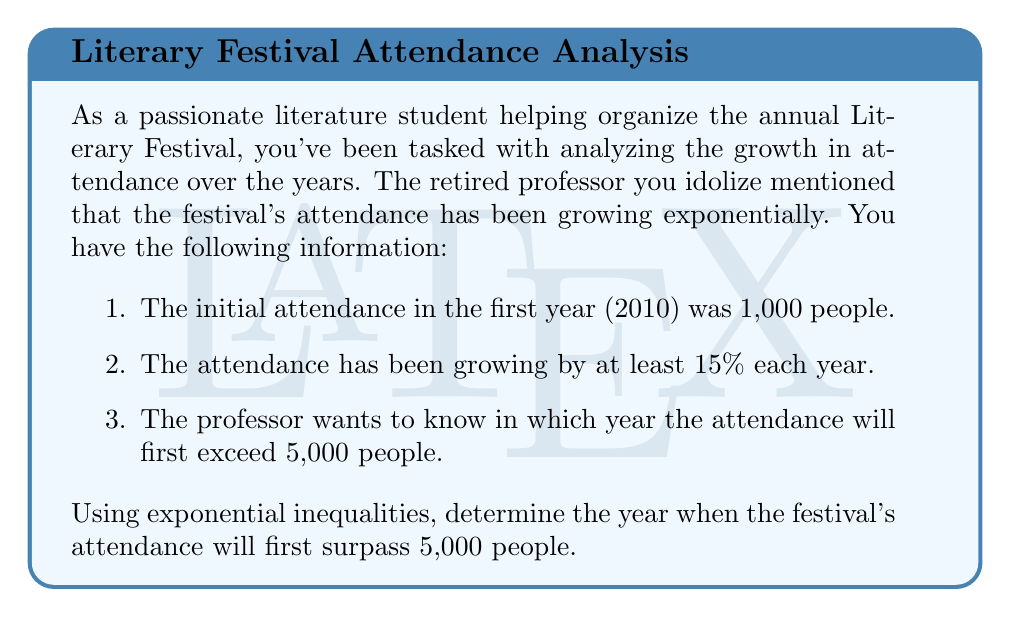Solve this math problem. Let's approach this step-by-step using exponential inequalities:

1. Let $x$ represent the number of years since 2010.
2. The initial attendance $A_0 = 1000$.
3. The growth rate is at least 15% per year, so we'll use 1.15 as our base.

We can express this as an exponential inequality:

$$1000 \cdot 1.15^x > 5000$$

Now, let's solve this inequality:

$$1.15^x > \frac{5000}{1000} = 5$$

Taking the natural logarithm of both sides:

$$x \cdot \ln(1.15) > \ln(5)$$

Dividing both sides by $\ln(1.15)$:

$$x > \frac{\ln(5)}{\ln(1.15)} \approx 11.77$$

Since $x$ represents years and must be a whole number, we need to round up to the next integer.

Therefore, $x = 12$.

To find the actual year, we add 12 to 2010:

2010 + 12 = 2022
Answer: The festival's attendance will first exceed 5,000 people in 2022. 